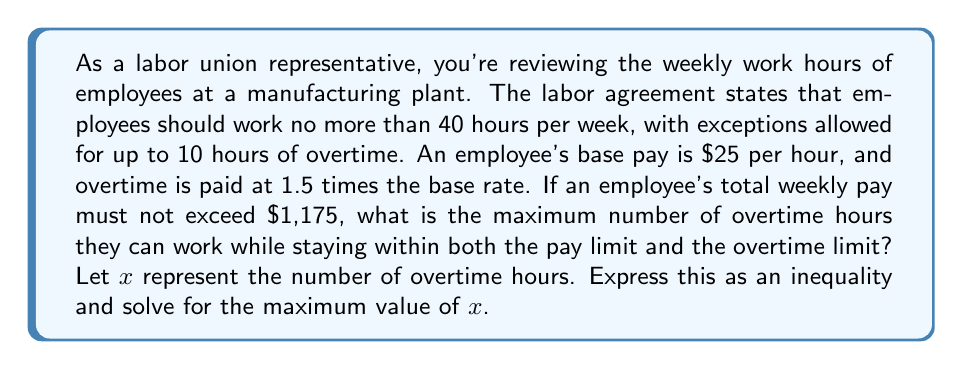Help me with this question. Let's approach this step-by-step:

1) First, let's set up our inequality based on the total weekly pay:

   $$(40 \times 25) + (x \times 25 \times 1.5) \leq 1175$$

2) Simplify the left side of the inequality:

   $$1000 + 37.5x \leq 1175$$

3) Subtract 1000 from both sides:

   $$37.5x \leq 175$$

4) Divide both sides by 37.5:

   $$x \leq \frac{175}{37.5} = \frac{14}{3} \approx 4.67$$

5) However, we also need to consider the overtime limit of 10 hours. So our complete inequality is:

   $$x \leq \min(\frac{14}{3}, 10)$$

6) Since $\frac{14}{3}$ is less than 10, this is our limiting factor.

7) As we're dealing with working hours, we need to round down to the nearest whole number.

Therefore, the maximum number of overtime hours is 4.
Answer: The maximum number of overtime hours the employee can work while staying within both the pay limit and the overtime limit is 4 hours. 